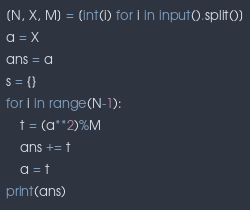<code> <loc_0><loc_0><loc_500><loc_500><_Python_>[N, X, M] = [int(i) for i in input().split()]
a = X
ans = a
s = {}
for i in range(N-1):
    t = (a**2)%M
    ans += t
    a = t
print(ans)</code> 